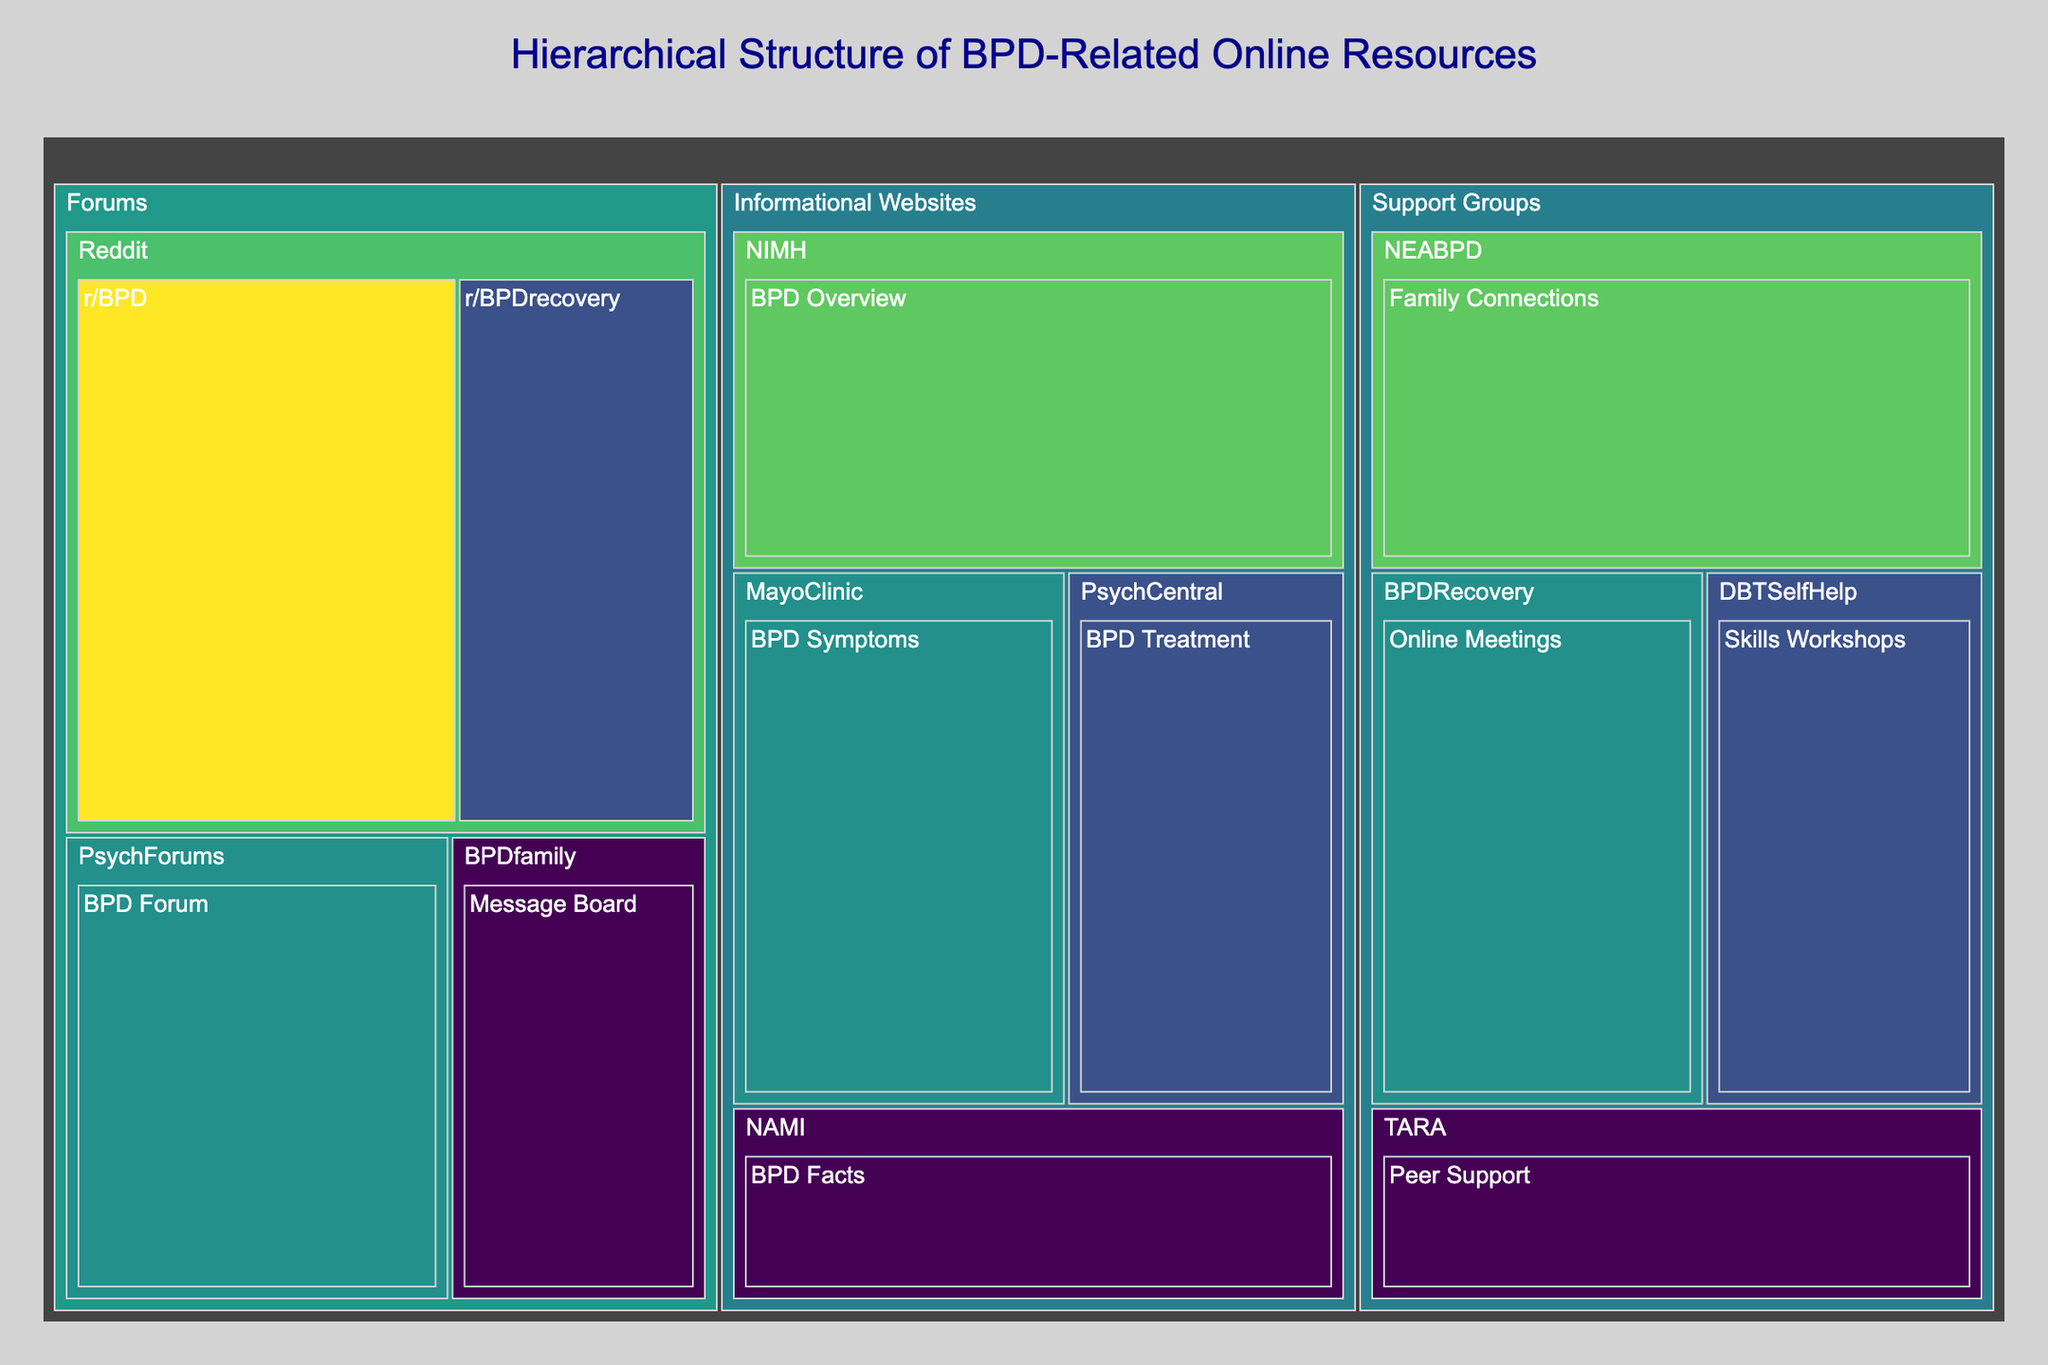What is the title of the figure? Look at the top of the figure where the title is typically placed.
Answer: Hierarchical Structure of BPD-Related Online Resources What is the value associated with the "r/BPD" resource? Find the "r/BPD" resource in the "Subcategory" labeled "Reddit" and note the corresponding value.
Answer: 40 Which subcategory within the "Support Groups" category has the highest value? Compare the values of the subcategories ("Family Connections", "Online Meetings", "Skills Workshops", "Peer Support") within the "Support Groups" category.
Answer: Family Connections What is the total value for all resources in the "Informational Websites" category? Sum the values of all resources within the "Informational Websites" category. The values are 35 (NIMH), 30 (MayoClinic), 25 (PsychCentral), and 20 (NAMI). The total is 35 + 30 + 25 + 20 = 110.
Answer: 110 How does the size of the "Message Board" in "BPDfamily" compare to "BPD Forum" in "PsychForums"? Compare the values of "Message Board" (20) and "BPD Forum" (30) to determine which is larger.
Answer: BPD Forum is larger What is the average value of the resources in the "Reddit" subcategory? Add the values of "r/BPD" (40) and "r/BPDrecovery" (25), then divide by the number of resources (2). The average is (40 + 25) / 2 = 32.5.
Answer: 32.5 What is the difference between the highest and lowest values in the figure? Identify the highest value (40 for "r/BPD") and the lowest value (20 for multiple resources like "Message Board", "BPD Facts", etc.), then calculate the difference: 40 - 20 = 20.
Answer: 20 Which category has the most number of subcategories? Identify the number of subcategories in each category. "Forums" and "Informational Websites" have 2 subcategories each, while "Support Groups" has 4. Thus, "Support Groups" has the most subcategories.
Answer: Support Groups Which resource in the "Support Groups" category has a value of 25? Look for the resource in the "Support Groups" category with the value 25, which is "Skills Workshops" in "DBTSelfHelp".
Answer: Skills Workshops How many resources have a value of 20? Count the number of resources with a value of 20. They are "Message Board" in "BPDfamily", "BPD Facts" in "NAMI", and "Peer Support" in "TARA".
Answer: 3 